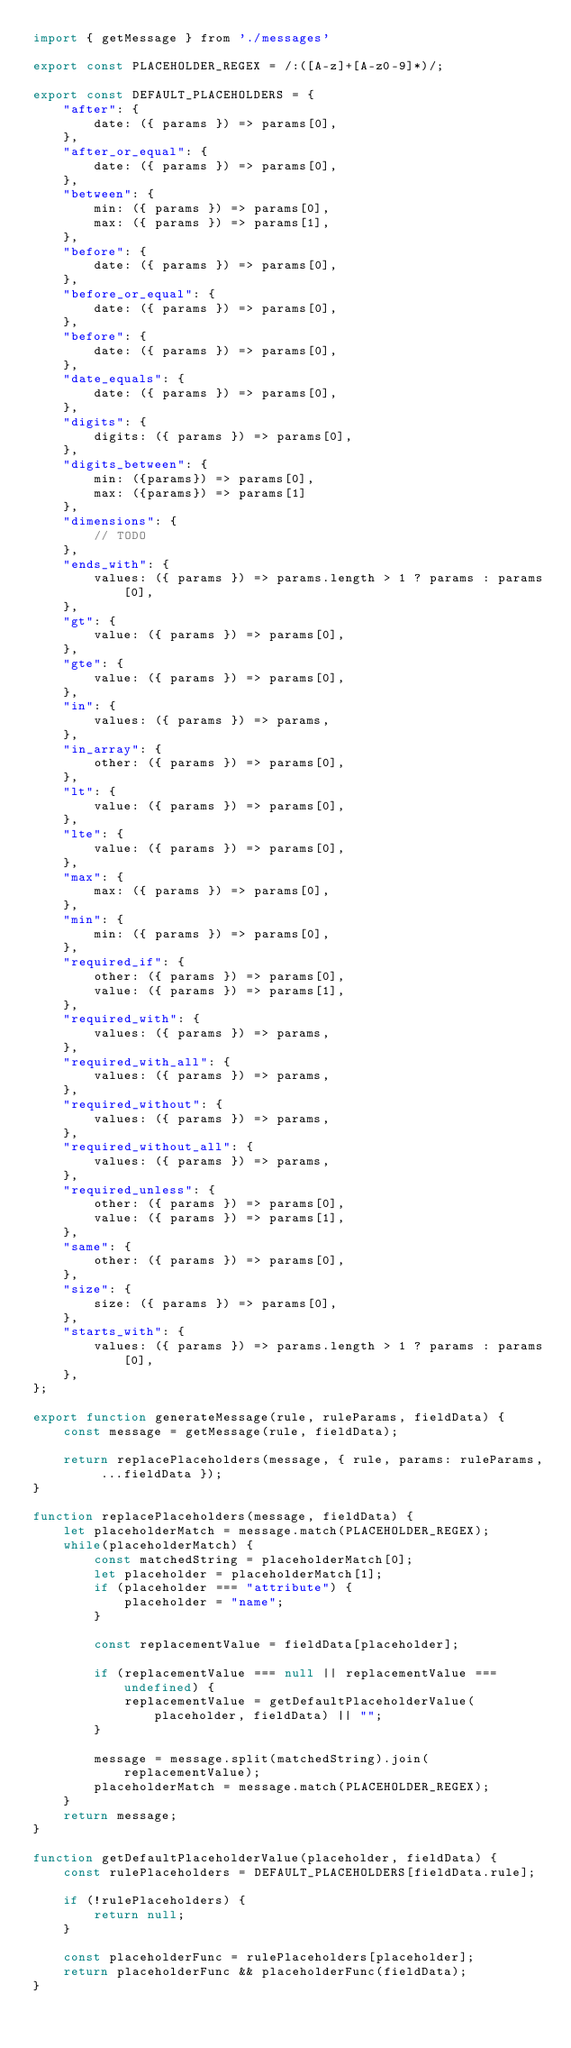<code> <loc_0><loc_0><loc_500><loc_500><_JavaScript_>import { getMessage } from './messages'

export const PLACEHOLDER_REGEX = /:([A-z]+[A-z0-9]*)/;

export const DEFAULT_PLACEHOLDERS = {
    "after": {
        date: ({ params }) => params[0],
    },
    "after_or_equal": {
        date: ({ params }) => params[0],
    },
    "between": {
        min: ({ params }) => params[0],
        max: ({ params }) => params[1], 
    },
    "before": {
        date: ({ params }) => params[0],
    },
    "before_or_equal": {
        date: ({ params }) => params[0],
    },
    "before": {
        date: ({ params }) => params[0],
    },
    "date_equals": {
        date: ({ params }) => params[0],
    },
    "digits": {
        digits: ({ params }) => params[0],
    },
    "digits_between": {
        min: ({params}) => params[0],
        max: ({params}) => params[1]
    },
    "dimensions": {
        // TODO
    },
    "ends_with": {
        values: ({ params }) => params.length > 1 ? params : params[0],
    },
    "gt": {
        value: ({ params }) => params[0],
    },
    "gte": {
        value: ({ params }) => params[0],
    },
    "in": {
        values: ({ params }) => params,
    },
    "in_array": {
        other: ({ params }) => params[0],
    },
    "lt": {
        value: ({ params }) => params[0],
    },
    "lte": {
        value: ({ params }) => params[0],
    },
    "max": {
        max: ({ params }) => params[0],
    },
    "min": {
        min: ({ params }) => params[0],
    },
    "required_if": {
        other: ({ params }) => params[0],
        value: ({ params }) => params[1],
    },
    "required_with": {
        values: ({ params }) => params,
    },
    "required_with_all": {
        values: ({ params }) => params,
    },
    "required_without": {
        values: ({ params }) => params,
    },
    "required_without_all": {
        values: ({ params }) => params,
    },
    "required_unless": {
        other: ({ params }) => params[0],
        value: ({ params }) => params[1],
    },
    "same": {
        other: ({ params }) => params[0],
    },
    "size": {
        size: ({ params }) => params[0],
    },
    "starts_with": {
        values: ({ params }) => params.length > 1 ? params : params[0],
    },
};

export function generateMessage(rule, ruleParams, fieldData) {
    const message = getMessage(rule, fieldData);

    return replacePlaceholders(message, { rule, params: ruleParams, ...fieldData });
}

function replacePlaceholders(message, fieldData) {
    let placeholderMatch = message.match(PLACEHOLDER_REGEX);
    while(placeholderMatch) {
        const matchedString = placeholderMatch[0];
        let placeholder = placeholderMatch[1];
        if (placeholder === "attribute") {
            placeholder = "name";
        }

        const replacementValue = fieldData[placeholder];

        if (replacementValue === null || replacementValue === undefined) {
            replacementValue = getDefaultPlaceholderValue(placeholder, fieldData) || "";
        }

        message = message.split(matchedString).join(replacementValue);
        placeholderMatch = message.match(PLACEHOLDER_REGEX);
    }
    return message;
}

function getDefaultPlaceholderValue(placeholder, fieldData) {
    const rulePlaceholders = DEFAULT_PLACEHOLDERS[fieldData.rule];

    if (!rulePlaceholders) {
        return null;
    }

    const placeholderFunc = rulePlaceholders[placeholder];
    return placeholderFunc && placeholderFunc(fieldData);
}</code> 